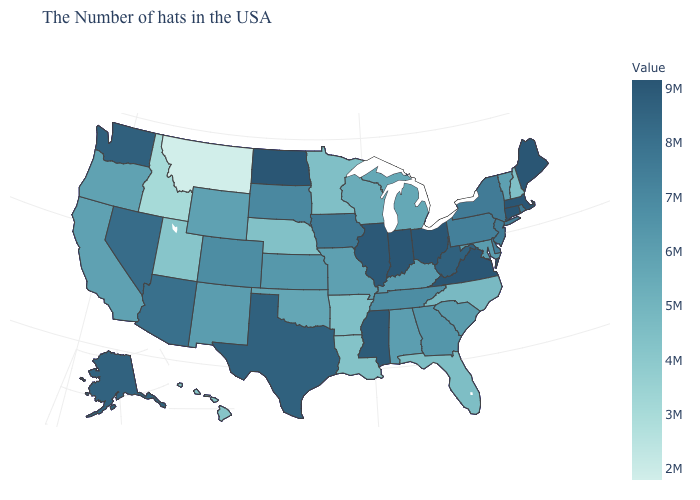Among the states that border Idaho , does Washington have the highest value?
Quick response, please. Yes. Which states have the lowest value in the USA?
Be succinct. Montana. Which states hav the highest value in the Northeast?
Concise answer only. Maine, Massachusetts, Connecticut. Which states have the highest value in the USA?
Write a very short answer. Maine, Massachusetts, Connecticut, Virginia, Ohio, Indiana, North Dakota. 